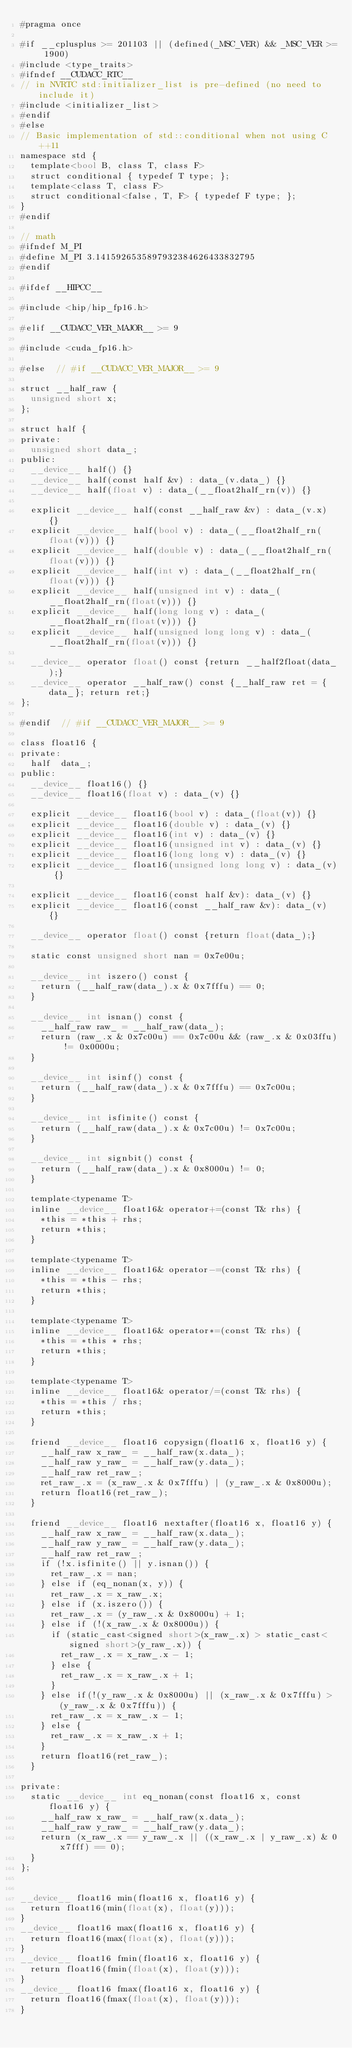Convert code to text. <code><loc_0><loc_0><loc_500><loc_500><_Cuda_>#pragma once

#if __cplusplus >= 201103 || (defined(_MSC_VER) && _MSC_VER >= 1900)
#include <type_traits>
#ifndef __CUDACC_RTC__
// in NVRTC std:initializer_list is pre-defined (no need to include it)
#include <initializer_list>
#endif
#else
// Basic implementation of std::conditional when not using C++11
namespace std {
  template<bool B, class T, class F>
  struct conditional { typedef T type; };
  template<class T, class F>
  struct conditional<false, T, F> { typedef F type; };
}
#endif

// math
#ifndef M_PI
#define M_PI 3.1415926535897932384626433832795
#endif

#ifdef __HIPCC__

#include <hip/hip_fp16.h>

#elif __CUDACC_VER_MAJOR__ >= 9

#include <cuda_fp16.h>

#else  // #if __CUDACC_VER_MAJOR__ >= 9

struct __half_raw {
  unsigned short x;
};

struct half {
private:
  unsigned short data_;
public:
  __device__ half() {}
  __device__ half(const half &v) : data_(v.data_) {}
  __device__ half(float v) : data_(__float2half_rn(v)) {}

  explicit __device__ half(const __half_raw &v) : data_(v.x) {}
  explicit __device__ half(bool v) : data_(__float2half_rn(float(v))) {}
  explicit __device__ half(double v) : data_(__float2half_rn(float(v))) {}
  explicit __device__ half(int v) : data_(__float2half_rn(float(v))) {}
  explicit __device__ half(unsigned int v) : data_(__float2half_rn(float(v))) {}
  explicit __device__ half(long long v) : data_(__float2half_rn(float(v))) {}
  explicit __device__ half(unsigned long long v) : data_(__float2half_rn(float(v))) {}

  __device__ operator float() const {return __half2float(data_);}
  __device__ operator __half_raw() const {__half_raw ret = {data_}; return ret;}
};

#endif  // #if __CUDACC_VER_MAJOR__ >= 9

class float16 {
private:
  half  data_;
public:
  __device__ float16() {}
  __device__ float16(float v) : data_(v) {}

  explicit __device__ float16(bool v) : data_(float(v)) {}
  explicit __device__ float16(double v) : data_(v) {}
  explicit __device__ float16(int v) : data_(v) {}
  explicit __device__ float16(unsigned int v) : data_(v) {}
  explicit __device__ float16(long long v) : data_(v) {}
  explicit __device__ float16(unsigned long long v) : data_(v) {}

  explicit __device__ float16(const half &v): data_(v) {}
  explicit __device__ float16(const __half_raw &v): data_(v) {}

  __device__ operator float() const {return float(data_);}

  static const unsigned short nan = 0x7e00u;

  __device__ int iszero() const {
    return (__half_raw(data_).x & 0x7fffu) == 0;
  }

  __device__ int isnan() const {
    __half_raw raw_ = __half_raw(data_);
    return (raw_.x & 0x7c00u) == 0x7c00u && (raw_.x & 0x03ffu) != 0x0000u;
  }

  __device__ int isinf() const {
    return (__half_raw(data_).x & 0x7fffu) == 0x7c00u;
  }

  __device__ int isfinite() const {
    return (__half_raw(data_).x & 0x7c00u) != 0x7c00u;
  }

  __device__ int signbit() const {
    return (__half_raw(data_).x & 0x8000u) != 0;
  }

  template<typename T>
  inline __device__ float16& operator+=(const T& rhs) {
    *this = *this + rhs;
    return *this;
  }

  template<typename T>
  inline __device__ float16& operator-=(const T& rhs) {
    *this = *this - rhs;
    return *this;
  }

  template<typename T>
  inline __device__ float16& operator*=(const T& rhs) {
    *this = *this * rhs;
    return *this;
  }

  template<typename T>
  inline __device__ float16& operator/=(const T& rhs) {
    *this = *this / rhs;
    return *this;
  }

  friend __device__ float16 copysign(float16 x, float16 y) {
    __half_raw x_raw_ = __half_raw(x.data_);
    __half_raw y_raw_ = __half_raw(y.data_);
    __half_raw ret_raw_;
    ret_raw_.x = (x_raw_.x & 0x7fffu) | (y_raw_.x & 0x8000u);
    return float16(ret_raw_);
  }

  friend __device__ float16 nextafter(float16 x, float16 y) {
    __half_raw x_raw_ = __half_raw(x.data_);
    __half_raw y_raw_ = __half_raw(y.data_);
    __half_raw ret_raw_;
    if (!x.isfinite() || y.isnan()) {
      ret_raw_.x = nan;
    } else if (eq_nonan(x, y)) {
      ret_raw_.x = x_raw_.x;
    } else if (x.iszero()) {
      ret_raw_.x = (y_raw_.x & 0x8000u) + 1;
    } else if (!(x_raw_.x & 0x8000u)) {
      if (static_cast<signed short>(x_raw_.x) > static_cast<signed short>(y_raw_.x)) {
        ret_raw_.x = x_raw_.x - 1;
      } else {
        ret_raw_.x = x_raw_.x + 1;
      }
    } else if(!(y_raw_.x & 0x8000u) || (x_raw_.x & 0x7fffu) > (y_raw_.x & 0x7fffu)) {
      ret_raw_.x = x_raw_.x - 1;
    } else {
      ret_raw_.x = x_raw_.x + 1;
    }
    return float16(ret_raw_);
  }

private:
  static __device__ int eq_nonan(const float16 x, const float16 y) {
    __half_raw x_raw_ = __half_raw(x.data_);
    __half_raw y_raw_ = __half_raw(y.data_);
    return (x_raw_.x == y_raw_.x || ((x_raw_.x | y_raw_.x) & 0x7fff) == 0);
  }
};


__device__ float16 min(float16 x, float16 y) {
  return float16(min(float(x), float(y)));
}
__device__ float16 max(float16 x, float16 y) {
  return float16(max(float(x), float(y)));
}
__device__ float16 fmin(float16 x, float16 y) {
  return float16(fmin(float(x), float(y)));
}
__device__ float16 fmax(float16 x, float16 y) {
  return float16(fmax(float(x), float(y)));
}</code> 